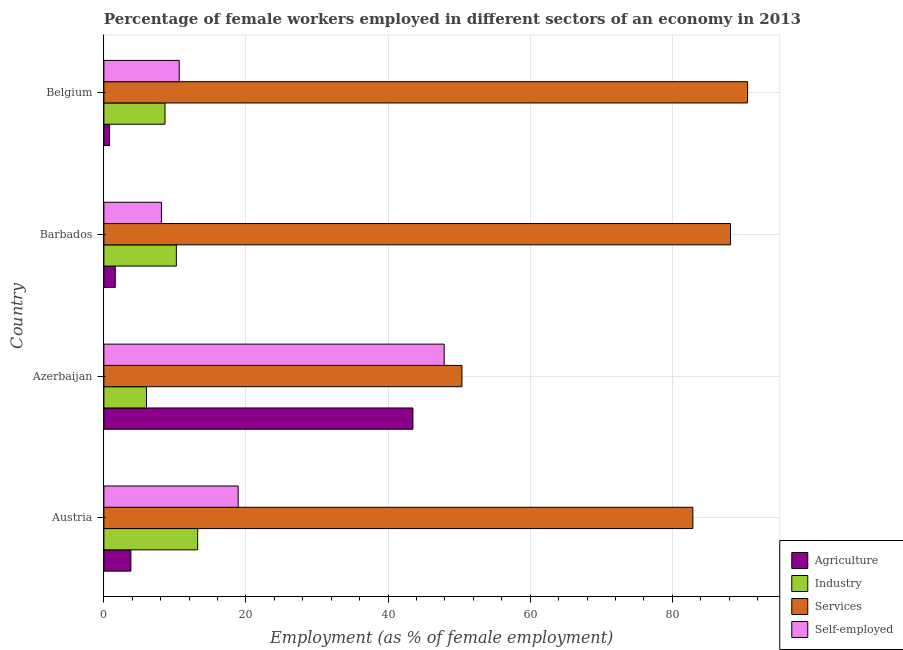How many groups of bars are there?
Keep it short and to the point. 4. How many bars are there on the 1st tick from the bottom?
Provide a succinct answer. 4. What is the percentage of female workers in services in Barbados?
Ensure brevity in your answer.  88.2. Across all countries, what is the maximum percentage of female workers in agriculture?
Keep it short and to the point. 43.5. Across all countries, what is the minimum percentage of female workers in industry?
Keep it short and to the point. 6. In which country was the percentage of female workers in industry maximum?
Your response must be concise. Austria. In which country was the percentage of self employed female workers minimum?
Offer a very short reply. Barbados. What is the total percentage of female workers in services in the graph?
Keep it short and to the point. 312.1. What is the difference between the percentage of female workers in agriculture in Azerbaijan and that in Barbados?
Offer a terse response. 41.9. What is the difference between the percentage of female workers in agriculture in Azerbaijan and the percentage of female workers in industry in Barbados?
Ensure brevity in your answer.  33.3. What is the average percentage of female workers in industry per country?
Ensure brevity in your answer.  9.5. What is the ratio of the percentage of self employed female workers in Azerbaijan to that in Belgium?
Offer a very short reply. 4.52. Is the difference between the percentage of self employed female workers in Austria and Barbados greater than the difference between the percentage of female workers in services in Austria and Barbados?
Your response must be concise. Yes. What is the difference between the highest and the second highest percentage of self employed female workers?
Your answer should be very brief. 29. What is the difference between the highest and the lowest percentage of female workers in agriculture?
Your response must be concise. 42.7. In how many countries, is the percentage of female workers in services greater than the average percentage of female workers in services taken over all countries?
Give a very brief answer. 3. Is the sum of the percentage of female workers in services in Azerbaijan and Barbados greater than the maximum percentage of female workers in industry across all countries?
Offer a terse response. Yes. What does the 4th bar from the top in Azerbaijan represents?
Your answer should be very brief. Agriculture. What does the 2nd bar from the bottom in Austria represents?
Provide a succinct answer. Industry. Is it the case that in every country, the sum of the percentage of female workers in agriculture and percentage of female workers in industry is greater than the percentage of female workers in services?
Provide a short and direct response. No. How many bars are there?
Provide a succinct answer. 16. How many countries are there in the graph?
Offer a very short reply. 4. Are the values on the major ticks of X-axis written in scientific E-notation?
Keep it short and to the point. No. Does the graph contain any zero values?
Your response must be concise. No. Where does the legend appear in the graph?
Offer a very short reply. Bottom right. How many legend labels are there?
Your answer should be compact. 4. What is the title of the graph?
Offer a terse response. Percentage of female workers employed in different sectors of an economy in 2013. What is the label or title of the X-axis?
Offer a terse response. Employment (as % of female employment). What is the Employment (as % of female employment) of Agriculture in Austria?
Offer a very short reply. 3.8. What is the Employment (as % of female employment) in Industry in Austria?
Offer a terse response. 13.2. What is the Employment (as % of female employment) of Services in Austria?
Give a very brief answer. 82.9. What is the Employment (as % of female employment) of Self-employed in Austria?
Your answer should be compact. 18.9. What is the Employment (as % of female employment) in Agriculture in Azerbaijan?
Your answer should be very brief. 43.5. What is the Employment (as % of female employment) in Industry in Azerbaijan?
Provide a succinct answer. 6. What is the Employment (as % of female employment) in Services in Azerbaijan?
Your response must be concise. 50.4. What is the Employment (as % of female employment) of Self-employed in Azerbaijan?
Provide a short and direct response. 47.9. What is the Employment (as % of female employment) in Agriculture in Barbados?
Your answer should be very brief. 1.6. What is the Employment (as % of female employment) of Industry in Barbados?
Your response must be concise. 10.2. What is the Employment (as % of female employment) of Services in Barbados?
Offer a very short reply. 88.2. What is the Employment (as % of female employment) in Self-employed in Barbados?
Provide a succinct answer. 8.1. What is the Employment (as % of female employment) of Agriculture in Belgium?
Keep it short and to the point. 0.8. What is the Employment (as % of female employment) of Industry in Belgium?
Make the answer very short. 8.6. What is the Employment (as % of female employment) of Services in Belgium?
Make the answer very short. 90.6. What is the Employment (as % of female employment) in Self-employed in Belgium?
Your answer should be very brief. 10.6. Across all countries, what is the maximum Employment (as % of female employment) in Agriculture?
Offer a terse response. 43.5. Across all countries, what is the maximum Employment (as % of female employment) of Industry?
Give a very brief answer. 13.2. Across all countries, what is the maximum Employment (as % of female employment) in Services?
Keep it short and to the point. 90.6. Across all countries, what is the maximum Employment (as % of female employment) of Self-employed?
Offer a terse response. 47.9. Across all countries, what is the minimum Employment (as % of female employment) of Agriculture?
Make the answer very short. 0.8. Across all countries, what is the minimum Employment (as % of female employment) in Industry?
Provide a succinct answer. 6. Across all countries, what is the minimum Employment (as % of female employment) of Services?
Offer a terse response. 50.4. Across all countries, what is the minimum Employment (as % of female employment) in Self-employed?
Offer a terse response. 8.1. What is the total Employment (as % of female employment) of Agriculture in the graph?
Provide a short and direct response. 49.7. What is the total Employment (as % of female employment) in Industry in the graph?
Provide a succinct answer. 38. What is the total Employment (as % of female employment) of Services in the graph?
Provide a succinct answer. 312.1. What is the total Employment (as % of female employment) of Self-employed in the graph?
Your answer should be compact. 85.5. What is the difference between the Employment (as % of female employment) of Agriculture in Austria and that in Azerbaijan?
Give a very brief answer. -39.7. What is the difference between the Employment (as % of female employment) of Industry in Austria and that in Azerbaijan?
Ensure brevity in your answer.  7.2. What is the difference between the Employment (as % of female employment) of Services in Austria and that in Azerbaijan?
Offer a terse response. 32.5. What is the difference between the Employment (as % of female employment) of Services in Austria and that in Barbados?
Your response must be concise. -5.3. What is the difference between the Employment (as % of female employment) of Industry in Austria and that in Belgium?
Provide a short and direct response. 4.6. What is the difference between the Employment (as % of female employment) in Agriculture in Azerbaijan and that in Barbados?
Ensure brevity in your answer.  41.9. What is the difference between the Employment (as % of female employment) of Services in Azerbaijan and that in Barbados?
Provide a succinct answer. -37.8. What is the difference between the Employment (as % of female employment) of Self-employed in Azerbaijan and that in Barbados?
Your answer should be compact. 39.8. What is the difference between the Employment (as % of female employment) in Agriculture in Azerbaijan and that in Belgium?
Your response must be concise. 42.7. What is the difference between the Employment (as % of female employment) in Industry in Azerbaijan and that in Belgium?
Offer a terse response. -2.6. What is the difference between the Employment (as % of female employment) in Services in Azerbaijan and that in Belgium?
Your response must be concise. -40.2. What is the difference between the Employment (as % of female employment) of Self-employed in Azerbaijan and that in Belgium?
Provide a short and direct response. 37.3. What is the difference between the Employment (as % of female employment) in Services in Barbados and that in Belgium?
Your answer should be very brief. -2.4. What is the difference between the Employment (as % of female employment) of Agriculture in Austria and the Employment (as % of female employment) of Services in Azerbaijan?
Your response must be concise. -46.6. What is the difference between the Employment (as % of female employment) of Agriculture in Austria and the Employment (as % of female employment) of Self-employed in Azerbaijan?
Keep it short and to the point. -44.1. What is the difference between the Employment (as % of female employment) of Industry in Austria and the Employment (as % of female employment) of Services in Azerbaijan?
Keep it short and to the point. -37.2. What is the difference between the Employment (as % of female employment) of Industry in Austria and the Employment (as % of female employment) of Self-employed in Azerbaijan?
Provide a succinct answer. -34.7. What is the difference between the Employment (as % of female employment) in Services in Austria and the Employment (as % of female employment) in Self-employed in Azerbaijan?
Your answer should be very brief. 35. What is the difference between the Employment (as % of female employment) in Agriculture in Austria and the Employment (as % of female employment) in Services in Barbados?
Keep it short and to the point. -84.4. What is the difference between the Employment (as % of female employment) of Industry in Austria and the Employment (as % of female employment) of Services in Barbados?
Your answer should be compact. -75. What is the difference between the Employment (as % of female employment) of Services in Austria and the Employment (as % of female employment) of Self-employed in Barbados?
Your answer should be very brief. 74.8. What is the difference between the Employment (as % of female employment) of Agriculture in Austria and the Employment (as % of female employment) of Services in Belgium?
Your answer should be very brief. -86.8. What is the difference between the Employment (as % of female employment) of Agriculture in Austria and the Employment (as % of female employment) of Self-employed in Belgium?
Provide a short and direct response. -6.8. What is the difference between the Employment (as % of female employment) of Industry in Austria and the Employment (as % of female employment) of Services in Belgium?
Your response must be concise. -77.4. What is the difference between the Employment (as % of female employment) of Services in Austria and the Employment (as % of female employment) of Self-employed in Belgium?
Your response must be concise. 72.3. What is the difference between the Employment (as % of female employment) of Agriculture in Azerbaijan and the Employment (as % of female employment) of Industry in Barbados?
Your response must be concise. 33.3. What is the difference between the Employment (as % of female employment) in Agriculture in Azerbaijan and the Employment (as % of female employment) in Services in Barbados?
Give a very brief answer. -44.7. What is the difference between the Employment (as % of female employment) in Agriculture in Azerbaijan and the Employment (as % of female employment) in Self-employed in Barbados?
Your answer should be compact. 35.4. What is the difference between the Employment (as % of female employment) in Industry in Azerbaijan and the Employment (as % of female employment) in Services in Barbados?
Make the answer very short. -82.2. What is the difference between the Employment (as % of female employment) of Industry in Azerbaijan and the Employment (as % of female employment) of Self-employed in Barbados?
Provide a short and direct response. -2.1. What is the difference between the Employment (as % of female employment) in Services in Azerbaijan and the Employment (as % of female employment) in Self-employed in Barbados?
Your response must be concise. 42.3. What is the difference between the Employment (as % of female employment) in Agriculture in Azerbaijan and the Employment (as % of female employment) in Industry in Belgium?
Your answer should be compact. 34.9. What is the difference between the Employment (as % of female employment) in Agriculture in Azerbaijan and the Employment (as % of female employment) in Services in Belgium?
Provide a succinct answer. -47.1. What is the difference between the Employment (as % of female employment) in Agriculture in Azerbaijan and the Employment (as % of female employment) in Self-employed in Belgium?
Provide a succinct answer. 32.9. What is the difference between the Employment (as % of female employment) of Industry in Azerbaijan and the Employment (as % of female employment) of Services in Belgium?
Your answer should be compact. -84.6. What is the difference between the Employment (as % of female employment) in Services in Azerbaijan and the Employment (as % of female employment) in Self-employed in Belgium?
Make the answer very short. 39.8. What is the difference between the Employment (as % of female employment) in Agriculture in Barbados and the Employment (as % of female employment) in Services in Belgium?
Offer a terse response. -89. What is the difference between the Employment (as % of female employment) of Agriculture in Barbados and the Employment (as % of female employment) of Self-employed in Belgium?
Your response must be concise. -9. What is the difference between the Employment (as % of female employment) of Industry in Barbados and the Employment (as % of female employment) of Services in Belgium?
Your answer should be compact. -80.4. What is the difference between the Employment (as % of female employment) of Industry in Barbados and the Employment (as % of female employment) of Self-employed in Belgium?
Provide a short and direct response. -0.4. What is the difference between the Employment (as % of female employment) of Services in Barbados and the Employment (as % of female employment) of Self-employed in Belgium?
Provide a succinct answer. 77.6. What is the average Employment (as % of female employment) in Agriculture per country?
Ensure brevity in your answer.  12.43. What is the average Employment (as % of female employment) of Industry per country?
Ensure brevity in your answer.  9.5. What is the average Employment (as % of female employment) of Services per country?
Your answer should be compact. 78.03. What is the average Employment (as % of female employment) of Self-employed per country?
Provide a short and direct response. 21.38. What is the difference between the Employment (as % of female employment) of Agriculture and Employment (as % of female employment) of Services in Austria?
Your answer should be compact. -79.1. What is the difference between the Employment (as % of female employment) of Agriculture and Employment (as % of female employment) of Self-employed in Austria?
Provide a succinct answer. -15.1. What is the difference between the Employment (as % of female employment) of Industry and Employment (as % of female employment) of Services in Austria?
Offer a very short reply. -69.7. What is the difference between the Employment (as % of female employment) of Agriculture and Employment (as % of female employment) of Industry in Azerbaijan?
Provide a succinct answer. 37.5. What is the difference between the Employment (as % of female employment) in Agriculture and Employment (as % of female employment) in Services in Azerbaijan?
Provide a succinct answer. -6.9. What is the difference between the Employment (as % of female employment) in Agriculture and Employment (as % of female employment) in Self-employed in Azerbaijan?
Offer a very short reply. -4.4. What is the difference between the Employment (as % of female employment) of Industry and Employment (as % of female employment) of Services in Azerbaijan?
Offer a terse response. -44.4. What is the difference between the Employment (as % of female employment) of Industry and Employment (as % of female employment) of Self-employed in Azerbaijan?
Your answer should be compact. -41.9. What is the difference between the Employment (as % of female employment) in Services and Employment (as % of female employment) in Self-employed in Azerbaijan?
Provide a succinct answer. 2.5. What is the difference between the Employment (as % of female employment) of Agriculture and Employment (as % of female employment) of Industry in Barbados?
Provide a short and direct response. -8.6. What is the difference between the Employment (as % of female employment) in Agriculture and Employment (as % of female employment) in Services in Barbados?
Offer a terse response. -86.6. What is the difference between the Employment (as % of female employment) of Industry and Employment (as % of female employment) of Services in Barbados?
Make the answer very short. -78. What is the difference between the Employment (as % of female employment) of Industry and Employment (as % of female employment) of Self-employed in Barbados?
Give a very brief answer. 2.1. What is the difference between the Employment (as % of female employment) of Services and Employment (as % of female employment) of Self-employed in Barbados?
Ensure brevity in your answer.  80.1. What is the difference between the Employment (as % of female employment) in Agriculture and Employment (as % of female employment) in Industry in Belgium?
Your answer should be very brief. -7.8. What is the difference between the Employment (as % of female employment) of Agriculture and Employment (as % of female employment) of Services in Belgium?
Offer a very short reply. -89.8. What is the difference between the Employment (as % of female employment) of Industry and Employment (as % of female employment) of Services in Belgium?
Make the answer very short. -82. What is the difference between the Employment (as % of female employment) of Industry and Employment (as % of female employment) of Self-employed in Belgium?
Keep it short and to the point. -2. What is the difference between the Employment (as % of female employment) of Services and Employment (as % of female employment) of Self-employed in Belgium?
Provide a succinct answer. 80. What is the ratio of the Employment (as % of female employment) of Agriculture in Austria to that in Azerbaijan?
Provide a succinct answer. 0.09. What is the ratio of the Employment (as % of female employment) of Industry in Austria to that in Azerbaijan?
Your answer should be very brief. 2.2. What is the ratio of the Employment (as % of female employment) in Services in Austria to that in Azerbaijan?
Your response must be concise. 1.64. What is the ratio of the Employment (as % of female employment) in Self-employed in Austria to that in Azerbaijan?
Provide a short and direct response. 0.39. What is the ratio of the Employment (as % of female employment) of Agriculture in Austria to that in Barbados?
Your response must be concise. 2.38. What is the ratio of the Employment (as % of female employment) in Industry in Austria to that in Barbados?
Provide a short and direct response. 1.29. What is the ratio of the Employment (as % of female employment) of Services in Austria to that in Barbados?
Your answer should be very brief. 0.94. What is the ratio of the Employment (as % of female employment) in Self-employed in Austria to that in Barbados?
Your answer should be compact. 2.33. What is the ratio of the Employment (as % of female employment) of Agriculture in Austria to that in Belgium?
Provide a succinct answer. 4.75. What is the ratio of the Employment (as % of female employment) of Industry in Austria to that in Belgium?
Give a very brief answer. 1.53. What is the ratio of the Employment (as % of female employment) of Services in Austria to that in Belgium?
Keep it short and to the point. 0.92. What is the ratio of the Employment (as % of female employment) of Self-employed in Austria to that in Belgium?
Your answer should be very brief. 1.78. What is the ratio of the Employment (as % of female employment) in Agriculture in Azerbaijan to that in Barbados?
Make the answer very short. 27.19. What is the ratio of the Employment (as % of female employment) of Industry in Azerbaijan to that in Barbados?
Offer a very short reply. 0.59. What is the ratio of the Employment (as % of female employment) of Services in Azerbaijan to that in Barbados?
Your answer should be very brief. 0.57. What is the ratio of the Employment (as % of female employment) of Self-employed in Azerbaijan to that in Barbados?
Your answer should be very brief. 5.91. What is the ratio of the Employment (as % of female employment) of Agriculture in Azerbaijan to that in Belgium?
Your response must be concise. 54.38. What is the ratio of the Employment (as % of female employment) of Industry in Azerbaijan to that in Belgium?
Offer a terse response. 0.7. What is the ratio of the Employment (as % of female employment) in Services in Azerbaijan to that in Belgium?
Give a very brief answer. 0.56. What is the ratio of the Employment (as % of female employment) in Self-employed in Azerbaijan to that in Belgium?
Offer a very short reply. 4.52. What is the ratio of the Employment (as % of female employment) of Industry in Barbados to that in Belgium?
Keep it short and to the point. 1.19. What is the ratio of the Employment (as % of female employment) in Services in Barbados to that in Belgium?
Offer a very short reply. 0.97. What is the ratio of the Employment (as % of female employment) of Self-employed in Barbados to that in Belgium?
Give a very brief answer. 0.76. What is the difference between the highest and the second highest Employment (as % of female employment) in Agriculture?
Your answer should be compact. 39.7. What is the difference between the highest and the second highest Employment (as % of female employment) of Services?
Provide a short and direct response. 2.4. What is the difference between the highest and the second highest Employment (as % of female employment) of Self-employed?
Ensure brevity in your answer.  29. What is the difference between the highest and the lowest Employment (as % of female employment) in Agriculture?
Ensure brevity in your answer.  42.7. What is the difference between the highest and the lowest Employment (as % of female employment) in Services?
Provide a short and direct response. 40.2. What is the difference between the highest and the lowest Employment (as % of female employment) of Self-employed?
Your answer should be very brief. 39.8. 